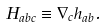<formula> <loc_0><loc_0><loc_500><loc_500>H _ { a b c } \equiv \nabla _ { c } h _ { a b } .</formula> 